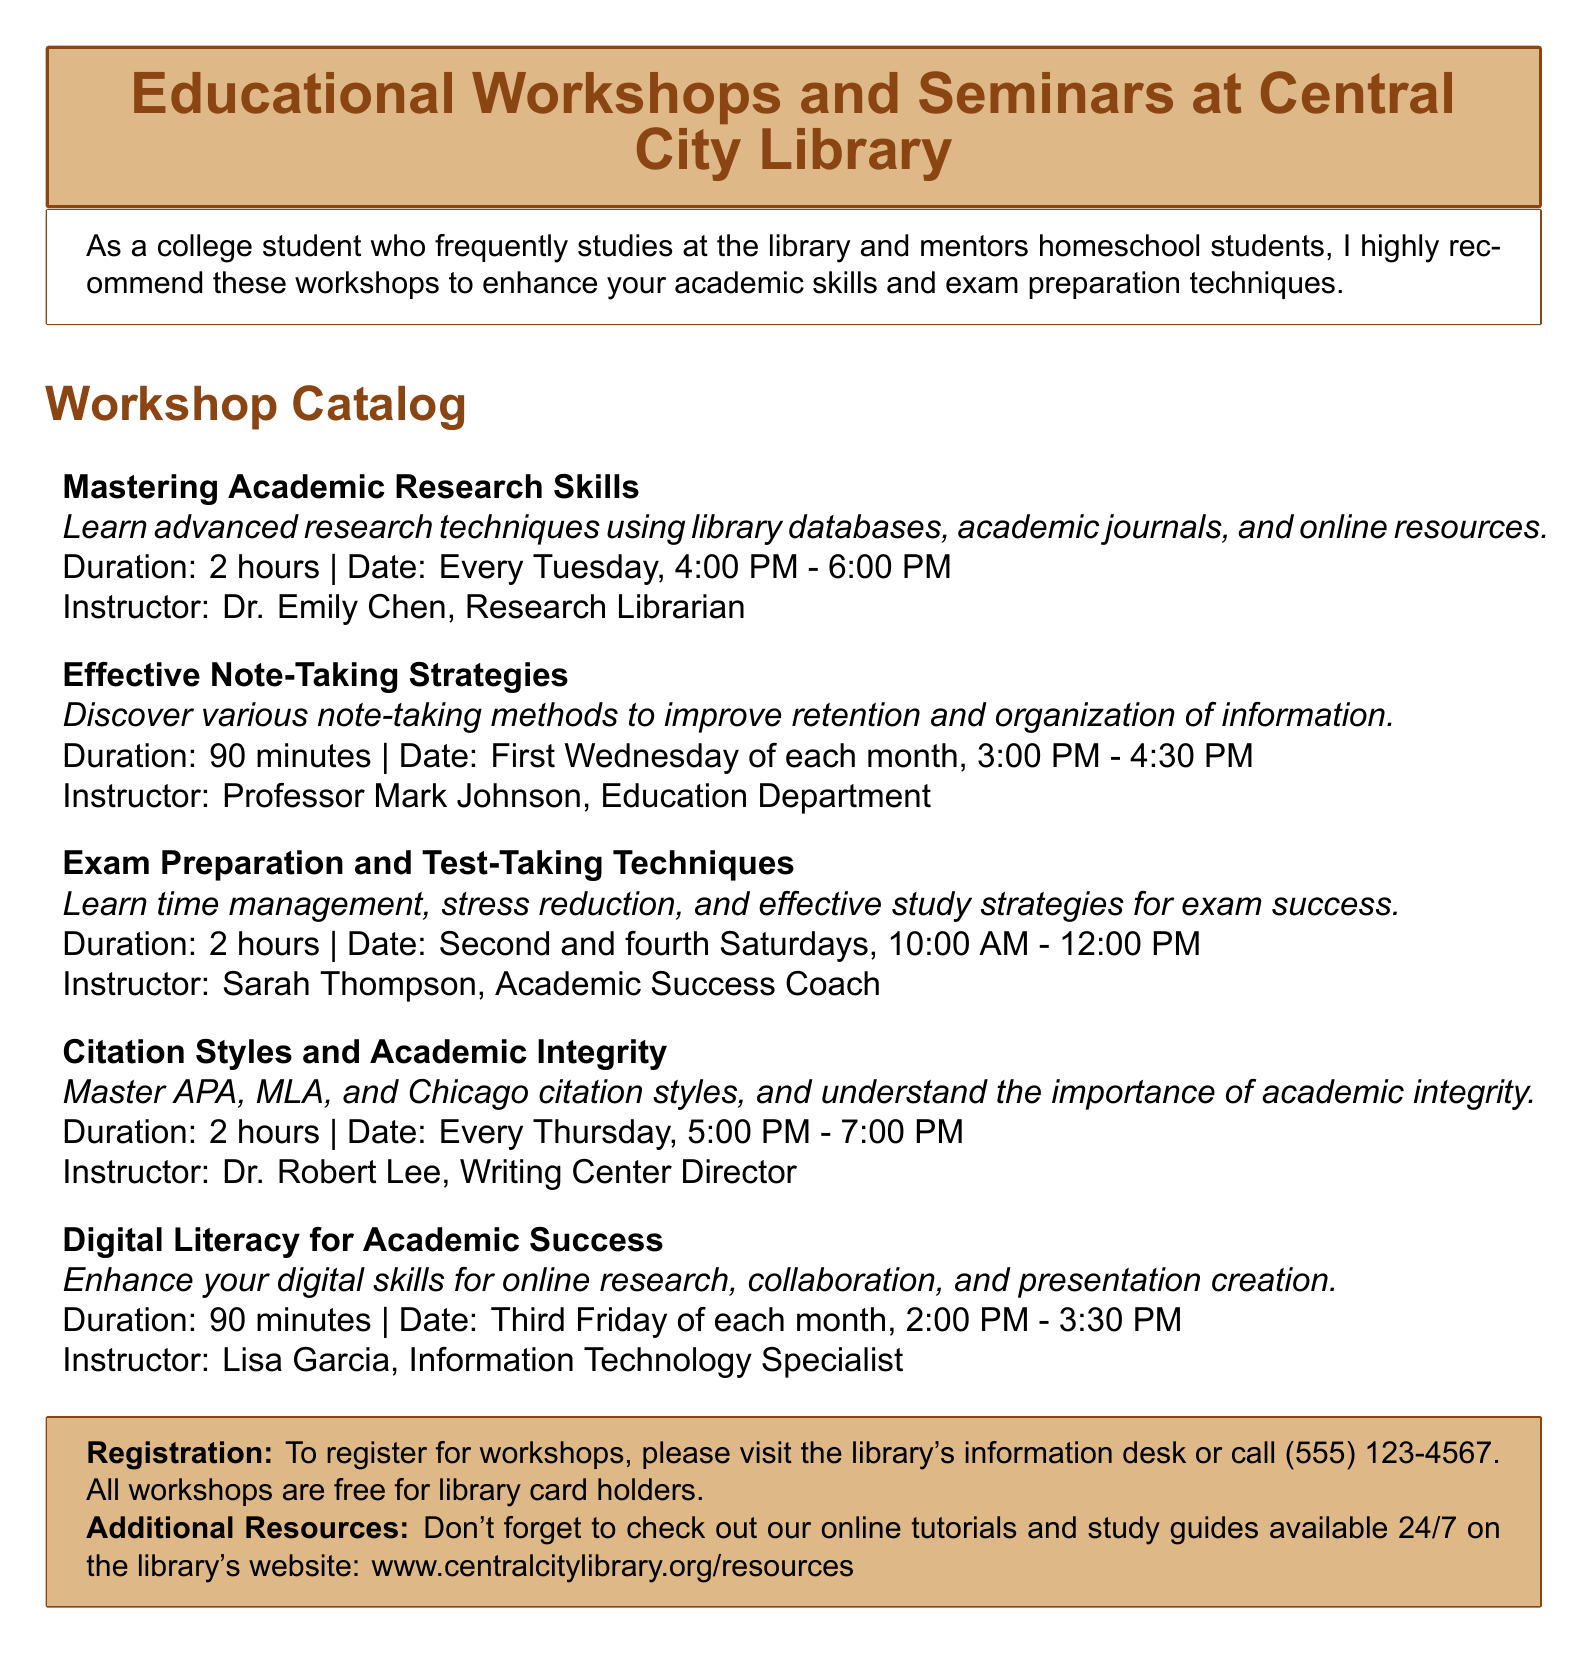What is the title of the first workshop? The title of the first workshop is mentioned in the document's list of workshops.
Answer: Mastering Academic Research Skills Who is the instructor for the "Exam Preparation and Test-Taking Techniques" workshop? The instructor's name is provided next to that workshop in the catalog.
Answer: Sarah Thompson How long is the "Effective Note-Taking Strategies" workshop? The duration is specified in the workshop description within the document.
Answer: 90 minutes When is the "Digital Literacy for Academic Success" workshop scheduled? The date for this workshop is provided in the document.
Answer: Third Friday of each month, 2:00 PM - 3:30 PM What citation styles are covered in the "Citation Styles and Academic Integrity" workshop? The document lists the citation styles included in this workshop.
Answer: APA, MLA, and Chicago How often is the "Mastering Academic Research Skills" workshop held? Frequency can be determined from the date mentioned in the document.
Answer: Every Tuesday What is required to register for the workshops? The registration requirement is explicitly stated in the document.
Answer: Library card holders What type of techniques are taught in the "Exam Preparation and Test-Taking Techniques" workshop? The document summarizes the focus of the workshop in the description.
Answer: Time management, stress reduction, effective study strategies 